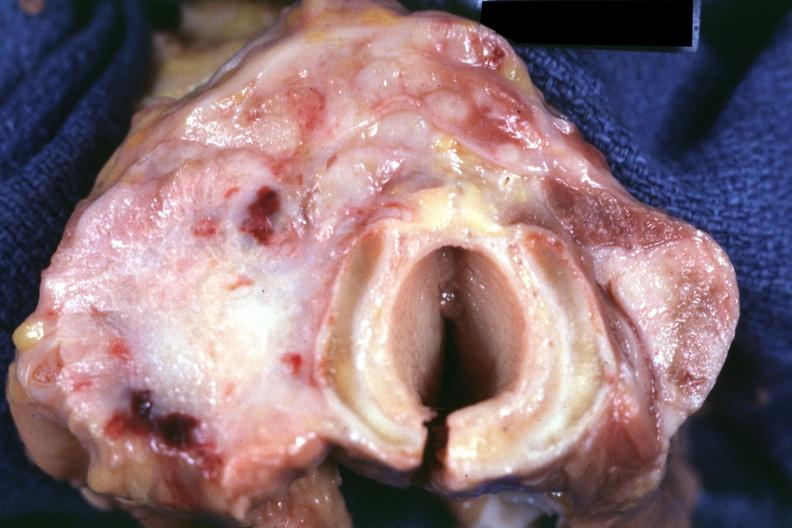where does this belong to?
Answer the question using a single word or phrase. Endocrine system 